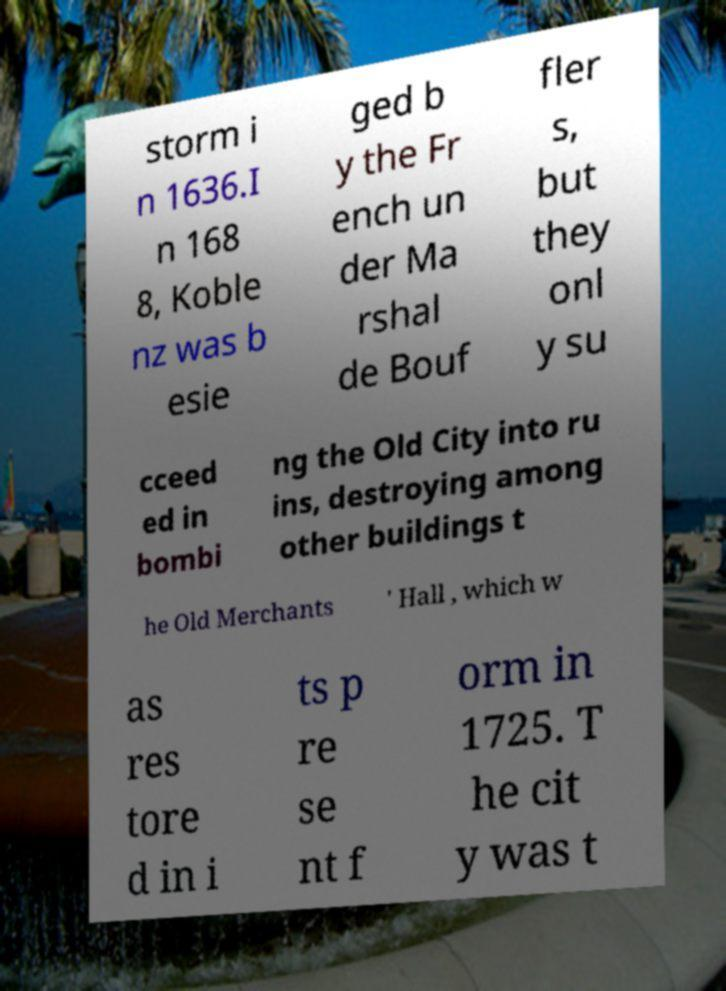Please identify and transcribe the text found in this image. storm i n 1636.I n 168 8, Koble nz was b esie ged b y the Fr ench un der Ma rshal de Bouf fler s, but they onl y su cceed ed in bombi ng the Old City into ru ins, destroying among other buildings t he Old Merchants ' Hall , which w as res tore d in i ts p re se nt f orm in 1725. T he cit y was t 